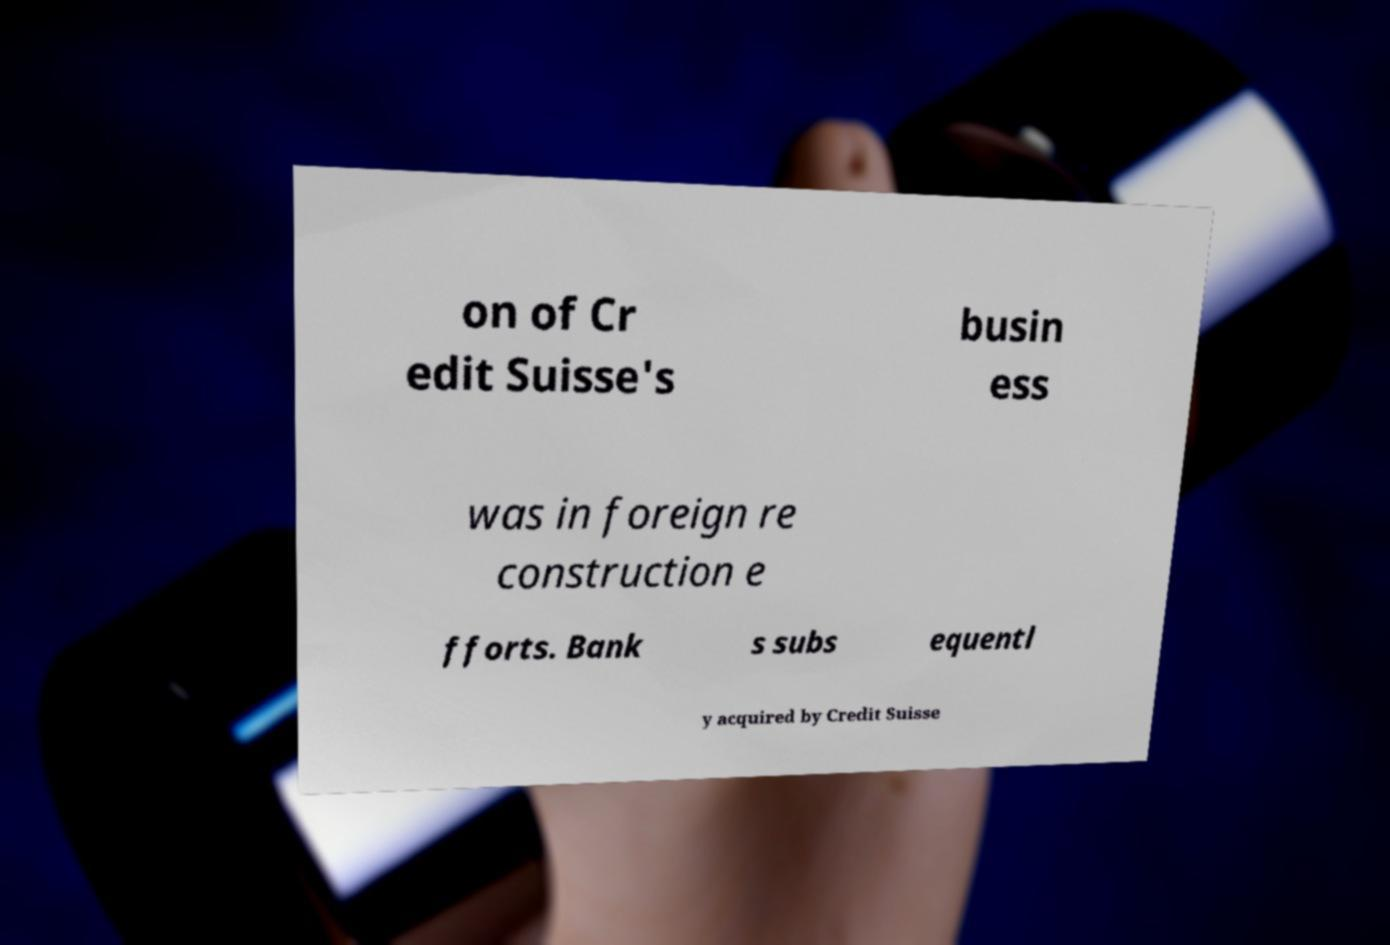Can you accurately transcribe the text from the provided image for me? on of Cr edit Suisse's busin ess was in foreign re construction e fforts. Bank s subs equentl y acquired by Credit Suisse 